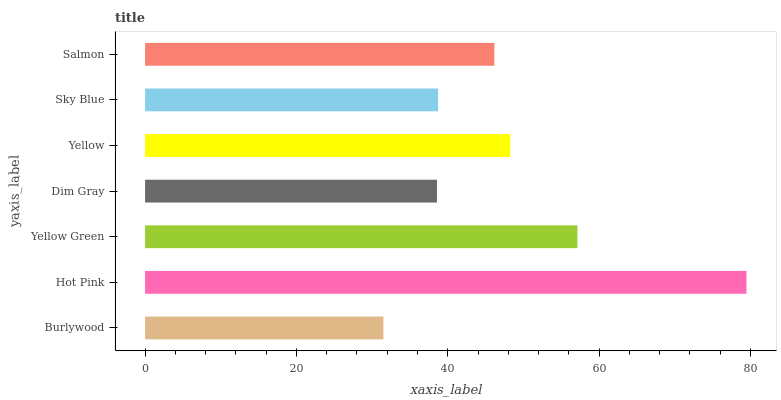Is Burlywood the minimum?
Answer yes or no. Yes. Is Hot Pink the maximum?
Answer yes or no. Yes. Is Yellow Green the minimum?
Answer yes or no. No. Is Yellow Green the maximum?
Answer yes or no. No. Is Hot Pink greater than Yellow Green?
Answer yes or no. Yes. Is Yellow Green less than Hot Pink?
Answer yes or no. Yes. Is Yellow Green greater than Hot Pink?
Answer yes or no. No. Is Hot Pink less than Yellow Green?
Answer yes or no. No. Is Salmon the high median?
Answer yes or no. Yes. Is Salmon the low median?
Answer yes or no. Yes. Is Burlywood the high median?
Answer yes or no. No. Is Sky Blue the low median?
Answer yes or no. No. 